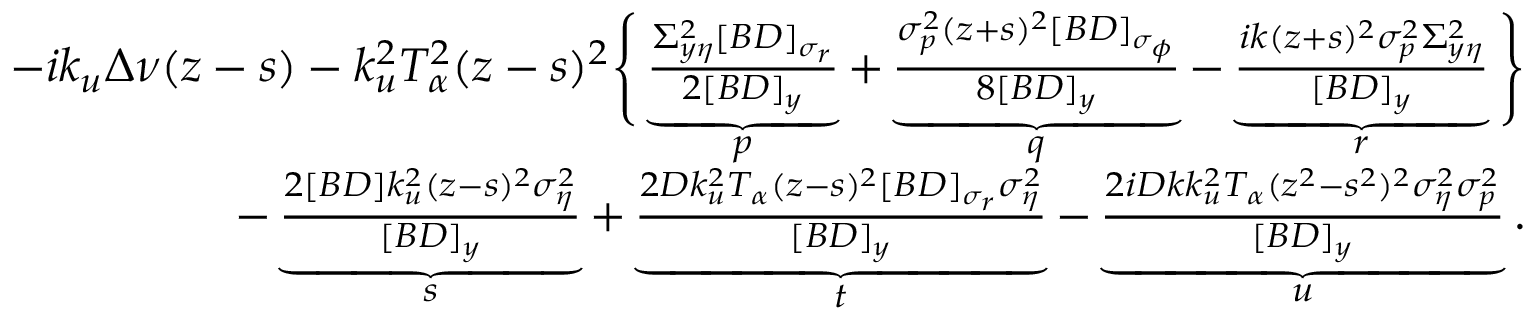Convert formula to latex. <formula><loc_0><loc_0><loc_500><loc_500>\begin{array} { r l r } & { - i k _ { u } \Delta \nu ( z - s ) - k _ { u } ^ { 2 } T _ { \alpha } ^ { 2 } ( z - s ) ^ { 2 } \left \{ \underbrace { \frac { \Sigma _ { y \eta } ^ { 2 } [ B D ] _ { \sigma _ { r } } } { 2 [ B D ] _ { y } } } _ { p } + \underbrace { \frac { \sigma _ { p } ^ { 2 } ( z + s ) ^ { 2 } [ B D ] _ { \sigma _ { \phi } } } { 8 [ B D ] _ { y } } } _ { q } - \underbrace { \frac { i k ( z + s ) ^ { 2 } \sigma _ { p } ^ { 2 } \Sigma _ { y \eta } ^ { 2 } } { [ B D ] _ { y } } } _ { r } \right \} } \\ & { \quad - \underbrace { \frac { 2 [ B D ] k _ { u } ^ { 2 } ( z - s ) ^ { 2 } \sigma _ { \eta } ^ { 2 } } { [ B D ] _ { y } } } _ { s } + \underbrace { \frac { 2 D k _ { u } ^ { 2 } T _ { \alpha } ( z - s ) ^ { 2 } [ B D ] _ { \sigma _ { r } } \sigma _ { \eta } ^ { 2 } } { [ B D ] _ { y } } } _ { t } - \underbrace { \frac { 2 i D k k _ { u } ^ { 2 } T _ { \alpha } ( z ^ { 2 } - s ^ { 2 } ) ^ { 2 } \sigma _ { \eta } ^ { 2 } \sigma _ { p } ^ { 2 } } { [ B D ] _ { y } } } _ { u } . } \end{array}</formula> 